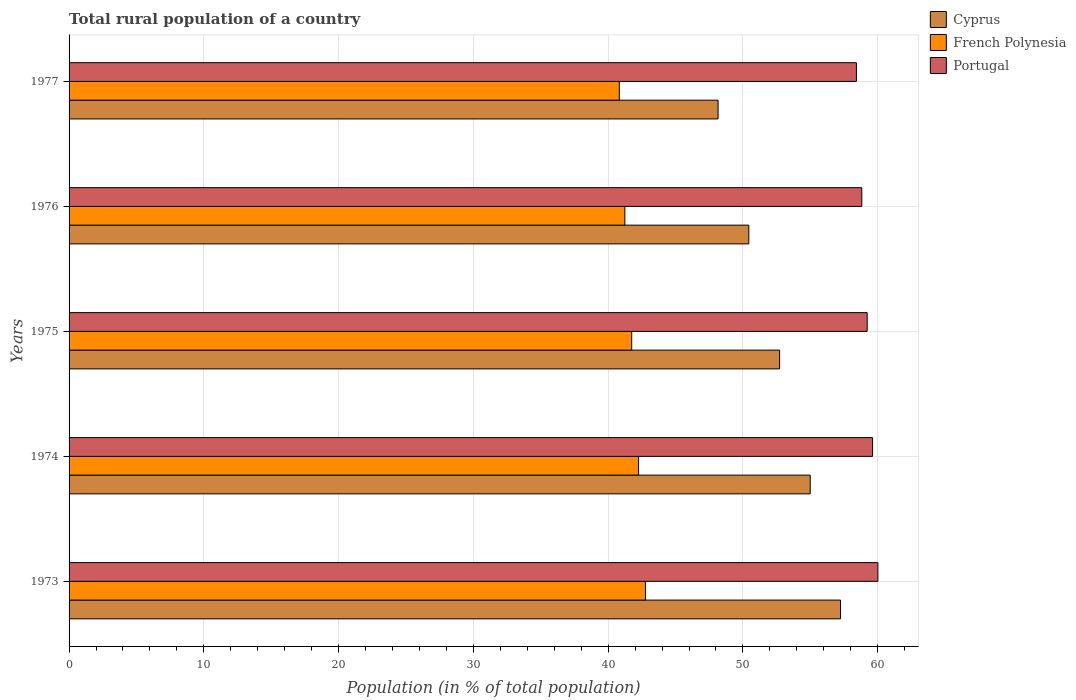How many different coloured bars are there?
Your answer should be compact. 3. Are the number of bars per tick equal to the number of legend labels?
Keep it short and to the point. Yes. Are the number of bars on each tick of the Y-axis equal?
Make the answer very short. Yes. How many bars are there on the 3rd tick from the top?
Provide a succinct answer. 3. How many bars are there on the 1st tick from the bottom?
Ensure brevity in your answer.  3. What is the label of the 3rd group of bars from the top?
Provide a succinct answer. 1975. In how many cases, is the number of bars for a given year not equal to the number of legend labels?
Your answer should be compact. 0. What is the rural population in French Polynesia in 1976?
Your answer should be very brief. 41.24. Across all years, what is the maximum rural population in Cyprus?
Your answer should be very brief. 57.24. Across all years, what is the minimum rural population in Portugal?
Provide a short and direct response. 58.42. What is the total rural population in Portugal in the graph?
Your answer should be compact. 296.1. What is the difference between the rural population in Portugal in 1974 and that in 1976?
Your answer should be compact. 0.8. What is the difference between the rural population in Cyprus in 1973 and the rural population in Portugal in 1976?
Make the answer very short. -1.58. What is the average rural population in French Polynesia per year?
Provide a succinct answer. 41.77. In the year 1977, what is the difference between the rural population in French Polynesia and rural population in Portugal?
Ensure brevity in your answer.  -17.59. What is the ratio of the rural population in Portugal in 1973 to that in 1975?
Give a very brief answer. 1.01. Is the rural population in Portugal in 1973 less than that in 1977?
Provide a short and direct response. No. Is the difference between the rural population in French Polynesia in 1976 and 1977 greater than the difference between the rural population in Portugal in 1976 and 1977?
Your response must be concise. Yes. What is the difference between the highest and the second highest rural population in Cyprus?
Offer a very short reply. 2.25. What is the difference between the highest and the lowest rural population in French Polynesia?
Your answer should be very brief. 1.94. Is the sum of the rural population in French Polynesia in 1973 and 1975 greater than the maximum rural population in Portugal across all years?
Ensure brevity in your answer.  Yes. What does the 3rd bar from the top in 1977 represents?
Keep it short and to the point. Cyprus. What does the 3rd bar from the bottom in 1975 represents?
Your answer should be compact. Portugal. Is it the case that in every year, the sum of the rural population in Cyprus and rural population in Portugal is greater than the rural population in French Polynesia?
Provide a short and direct response. Yes. Are all the bars in the graph horizontal?
Give a very brief answer. Yes. What is the difference between two consecutive major ticks on the X-axis?
Offer a very short reply. 10. Does the graph contain grids?
Your answer should be very brief. Yes. Where does the legend appear in the graph?
Give a very brief answer. Top right. How are the legend labels stacked?
Your answer should be compact. Vertical. What is the title of the graph?
Offer a very short reply. Total rural population of a country. Does "Armenia" appear as one of the legend labels in the graph?
Your response must be concise. No. What is the label or title of the X-axis?
Make the answer very short. Population (in % of total population). What is the Population (in % of total population) of Cyprus in 1973?
Offer a terse response. 57.24. What is the Population (in % of total population) in French Polynesia in 1973?
Offer a very short reply. 42.77. What is the Population (in % of total population) of Portugal in 1973?
Your answer should be compact. 60.02. What is the Population (in % of total population) of Cyprus in 1974?
Offer a very short reply. 54.99. What is the Population (in % of total population) in French Polynesia in 1974?
Ensure brevity in your answer.  42.26. What is the Population (in % of total population) in Portugal in 1974?
Keep it short and to the point. 59.62. What is the Population (in % of total population) of Cyprus in 1975?
Keep it short and to the point. 52.72. What is the Population (in % of total population) in French Polynesia in 1975?
Your answer should be compact. 41.75. What is the Population (in % of total population) of Portugal in 1975?
Your answer should be very brief. 59.22. What is the Population (in % of total population) in Cyprus in 1976?
Make the answer very short. 50.44. What is the Population (in % of total population) of French Polynesia in 1976?
Your response must be concise. 41.24. What is the Population (in % of total population) of Portugal in 1976?
Ensure brevity in your answer.  58.82. What is the Population (in % of total population) in Cyprus in 1977?
Offer a very short reply. 48.16. What is the Population (in % of total population) of French Polynesia in 1977?
Provide a succinct answer. 40.83. What is the Population (in % of total population) of Portugal in 1977?
Your response must be concise. 58.42. Across all years, what is the maximum Population (in % of total population) in Cyprus?
Offer a terse response. 57.24. Across all years, what is the maximum Population (in % of total population) of French Polynesia?
Offer a terse response. 42.77. Across all years, what is the maximum Population (in % of total population) in Portugal?
Your response must be concise. 60.02. Across all years, what is the minimum Population (in % of total population) of Cyprus?
Offer a very short reply. 48.16. Across all years, what is the minimum Population (in % of total population) of French Polynesia?
Offer a terse response. 40.83. Across all years, what is the minimum Population (in % of total population) of Portugal?
Provide a succinct answer. 58.42. What is the total Population (in % of total population) in Cyprus in the graph?
Provide a short and direct response. 263.55. What is the total Population (in % of total population) in French Polynesia in the graph?
Offer a terse response. 208.84. What is the total Population (in % of total population) in Portugal in the graph?
Your answer should be very brief. 296.1. What is the difference between the Population (in % of total population) of Cyprus in 1973 and that in 1974?
Your answer should be compact. 2.25. What is the difference between the Population (in % of total population) in French Polynesia in 1973 and that in 1974?
Offer a very short reply. 0.51. What is the difference between the Population (in % of total population) of Portugal in 1973 and that in 1974?
Offer a very short reply. 0.4. What is the difference between the Population (in % of total population) of Cyprus in 1973 and that in 1975?
Provide a succinct answer. 4.52. What is the difference between the Population (in % of total population) of Portugal in 1973 and that in 1975?
Your answer should be compact. 0.79. What is the difference between the Population (in % of total population) of Cyprus in 1973 and that in 1976?
Ensure brevity in your answer.  6.81. What is the difference between the Population (in % of total population) in French Polynesia in 1973 and that in 1976?
Provide a succinct answer. 1.53. What is the difference between the Population (in % of total population) in Portugal in 1973 and that in 1976?
Ensure brevity in your answer.  1.19. What is the difference between the Population (in % of total population) of Cyprus in 1973 and that in 1977?
Your answer should be very brief. 9.09. What is the difference between the Population (in % of total population) of French Polynesia in 1973 and that in 1977?
Provide a succinct answer. 1.94. What is the difference between the Population (in % of total population) of Portugal in 1973 and that in 1977?
Provide a short and direct response. 1.59. What is the difference between the Population (in % of total population) in Cyprus in 1974 and that in 1975?
Keep it short and to the point. 2.27. What is the difference between the Population (in % of total population) in French Polynesia in 1974 and that in 1975?
Give a very brief answer. 0.51. What is the difference between the Population (in % of total population) in Portugal in 1974 and that in 1975?
Offer a very short reply. 0.4. What is the difference between the Population (in % of total population) in Cyprus in 1974 and that in 1976?
Make the answer very short. 4.56. What is the difference between the Population (in % of total population) of Portugal in 1974 and that in 1976?
Your answer should be compact. 0.8. What is the difference between the Population (in % of total population) in Cyprus in 1974 and that in 1977?
Your answer should be compact. 6.84. What is the difference between the Population (in % of total population) in French Polynesia in 1974 and that in 1977?
Offer a terse response. 1.43. What is the difference between the Population (in % of total population) of Portugal in 1974 and that in 1977?
Offer a terse response. 1.2. What is the difference between the Population (in % of total population) of Cyprus in 1975 and that in 1976?
Your answer should be very brief. 2.29. What is the difference between the Population (in % of total population) in French Polynesia in 1975 and that in 1976?
Offer a very short reply. 0.51. What is the difference between the Population (in % of total population) in Portugal in 1975 and that in 1976?
Your answer should be compact. 0.4. What is the difference between the Population (in % of total population) of Cyprus in 1975 and that in 1977?
Keep it short and to the point. 4.57. What is the difference between the Population (in % of total population) of French Polynesia in 1975 and that in 1977?
Give a very brief answer. 0.92. What is the difference between the Population (in % of total population) in Portugal in 1975 and that in 1977?
Give a very brief answer. 0.8. What is the difference between the Population (in % of total population) of Cyprus in 1976 and that in 1977?
Give a very brief answer. 2.28. What is the difference between the Population (in % of total population) in French Polynesia in 1976 and that in 1977?
Keep it short and to the point. 0.41. What is the difference between the Population (in % of total population) of Portugal in 1976 and that in 1977?
Ensure brevity in your answer.  0.4. What is the difference between the Population (in % of total population) in Cyprus in 1973 and the Population (in % of total population) in French Polynesia in 1974?
Ensure brevity in your answer.  14.98. What is the difference between the Population (in % of total population) in Cyprus in 1973 and the Population (in % of total population) in Portugal in 1974?
Provide a succinct answer. -2.38. What is the difference between the Population (in % of total population) in French Polynesia in 1973 and the Population (in % of total population) in Portugal in 1974?
Your response must be concise. -16.85. What is the difference between the Population (in % of total population) of Cyprus in 1973 and the Population (in % of total population) of French Polynesia in 1975?
Give a very brief answer. 15.49. What is the difference between the Population (in % of total population) of Cyprus in 1973 and the Population (in % of total population) of Portugal in 1975?
Give a very brief answer. -1.98. What is the difference between the Population (in % of total population) in French Polynesia in 1973 and the Population (in % of total population) in Portugal in 1975?
Offer a very short reply. -16.45. What is the difference between the Population (in % of total population) in Cyprus in 1973 and the Population (in % of total population) in French Polynesia in 1976?
Your response must be concise. 16. What is the difference between the Population (in % of total population) of Cyprus in 1973 and the Population (in % of total population) of Portugal in 1976?
Your answer should be compact. -1.58. What is the difference between the Population (in % of total population) of French Polynesia in 1973 and the Population (in % of total population) of Portugal in 1976?
Your response must be concise. -16.05. What is the difference between the Population (in % of total population) of Cyprus in 1973 and the Population (in % of total population) of French Polynesia in 1977?
Your answer should be very brief. 16.41. What is the difference between the Population (in % of total population) in Cyprus in 1973 and the Population (in % of total population) in Portugal in 1977?
Keep it short and to the point. -1.18. What is the difference between the Population (in % of total population) of French Polynesia in 1973 and the Population (in % of total population) of Portugal in 1977?
Your answer should be very brief. -15.65. What is the difference between the Population (in % of total population) in Cyprus in 1974 and the Population (in % of total population) in French Polynesia in 1975?
Your response must be concise. 13.24. What is the difference between the Population (in % of total population) in Cyprus in 1974 and the Population (in % of total population) in Portugal in 1975?
Provide a short and direct response. -4.23. What is the difference between the Population (in % of total population) of French Polynesia in 1974 and the Population (in % of total population) of Portugal in 1975?
Provide a succinct answer. -16.96. What is the difference between the Population (in % of total population) of Cyprus in 1974 and the Population (in % of total population) of French Polynesia in 1976?
Your answer should be compact. 13.75. What is the difference between the Population (in % of total population) of Cyprus in 1974 and the Population (in % of total population) of Portugal in 1976?
Offer a very short reply. -3.83. What is the difference between the Population (in % of total population) in French Polynesia in 1974 and the Population (in % of total population) in Portugal in 1976?
Give a very brief answer. -16.56. What is the difference between the Population (in % of total population) in Cyprus in 1974 and the Population (in % of total population) in French Polynesia in 1977?
Keep it short and to the point. 14.16. What is the difference between the Population (in % of total population) in Cyprus in 1974 and the Population (in % of total population) in Portugal in 1977?
Make the answer very short. -3.43. What is the difference between the Population (in % of total population) in French Polynesia in 1974 and the Population (in % of total population) in Portugal in 1977?
Provide a short and direct response. -16.16. What is the difference between the Population (in % of total population) in Cyprus in 1975 and the Population (in % of total population) in French Polynesia in 1976?
Offer a very short reply. 11.48. What is the difference between the Population (in % of total population) of Cyprus in 1975 and the Population (in % of total population) of Portugal in 1976?
Provide a succinct answer. -6.1. What is the difference between the Population (in % of total population) in French Polynesia in 1975 and the Population (in % of total population) in Portugal in 1976?
Keep it short and to the point. -17.07. What is the difference between the Population (in % of total population) of Cyprus in 1975 and the Population (in % of total population) of French Polynesia in 1977?
Keep it short and to the point. 11.89. What is the difference between the Population (in % of total population) in Cyprus in 1975 and the Population (in % of total population) in Portugal in 1977?
Provide a succinct answer. -5.7. What is the difference between the Population (in % of total population) in French Polynesia in 1975 and the Population (in % of total population) in Portugal in 1977?
Your answer should be compact. -16.67. What is the difference between the Population (in % of total population) in Cyprus in 1976 and the Population (in % of total population) in French Polynesia in 1977?
Make the answer very short. 9.61. What is the difference between the Population (in % of total population) of Cyprus in 1976 and the Population (in % of total population) of Portugal in 1977?
Give a very brief answer. -7.99. What is the difference between the Population (in % of total population) of French Polynesia in 1976 and the Population (in % of total population) of Portugal in 1977?
Offer a terse response. -17.18. What is the average Population (in % of total population) in Cyprus per year?
Give a very brief answer. 52.71. What is the average Population (in % of total population) of French Polynesia per year?
Make the answer very short. 41.77. What is the average Population (in % of total population) in Portugal per year?
Give a very brief answer. 59.22. In the year 1973, what is the difference between the Population (in % of total population) in Cyprus and Population (in % of total population) in French Polynesia?
Your answer should be compact. 14.47. In the year 1973, what is the difference between the Population (in % of total population) in Cyprus and Population (in % of total population) in Portugal?
Provide a succinct answer. -2.77. In the year 1973, what is the difference between the Population (in % of total population) of French Polynesia and Population (in % of total population) of Portugal?
Provide a succinct answer. -17.25. In the year 1974, what is the difference between the Population (in % of total population) in Cyprus and Population (in % of total population) in French Polynesia?
Your answer should be compact. 12.73. In the year 1974, what is the difference between the Population (in % of total population) of Cyprus and Population (in % of total population) of Portugal?
Give a very brief answer. -4.62. In the year 1974, what is the difference between the Population (in % of total population) of French Polynesia and Population (in % of total population) of Portugal?
Your answer should be very brief. -17.36. In the year 1975, what is the difference between the Population (in % of total population) in Cyprus and Population (in % of total population) in French Polynesia?
Offer a very short reply. 10.97. In the year 1975, what is the difference between the Population (in % of total population) in Cyprus and Population (in % of total population) in Portugal?
Provide a succinct answer. -6.5. In the year 1975, what is the difference between the Population (in % of total population) of French Polynesia and Population (in % of total population) of Portugal?
Your answer should be very brief. -17.47. In the year 1976, what is the difference between the Population (in % of total population) of Cyprus and Population (in % of total population) of French Polynesia?
Offer a very short reply. 9.2. In the year 1976, what is the difference between the Population (in % of total population) in Cyprus and Population (in % of total population) in Portugal?
Offer a very short reply. -8.38. In the year 1976, what is the difference between the Population (in % of total population) in French Polynesia and Population (in % of total population) in Portugal?
Keep it short and to the point. -17.58. In the year 1977, what is the difference between the Population (in % of total population) of Cyprus and Population (in % of total population) of French Polynesia?
Provide a succinct answer. 7.33. In the year 1977, what is the difference between the Population (in % of total population) of Cyprus and Population (in % of total population) of Portugal?
Keep it short and to the point. -10.27. In the year 1977, what is the difference between the Population (in % of total population) in French Polynesia and Population (in % of total population) in Portugal?
Your answer should be compact. -17.59. What is the ratio of the Population (in % of total population) of Cyprus in 1973 to that in 1974?
Offer a terse response. 1.04. What is the ratio of the Population (in % of total population) of French Polynesia in 1973 to that in 1974?
Make the answer very short. 1.01. What is the ratio of the Population (in % of total population) of Portugal in 1973 to that in 1974?
Give a very brief answer. 1.01. What is the ratio of the Population (in % of total population) in Cyprus in 1973 to that in 1975?
Provide a succinct answer. 1.09. What is the ratio of the Population (in % of total population) in French Polynesia in 1973 to that in 1975?
Offer a very short reply. 1.02. What is the ratio of the Population (in % of total population) in Portugal in 1973 to that in 1975?
Ensure brevity in your answer.  1.01. What is the ratio of the Population (in % of total population) in Cyprus in 1973 to that in 1976?
Give a very brief answer. 1.13. What is the ratio of the Population (in % of total population) in French Polynesia in 1973 to that in 1976?
Make the answer very short. 1.04. What is the ratio of the Population (in % of total population) of Portugal in 1973 to that in 1976?
Provide a succinct answer. 1.02. What is the ratio of the Population (in % of total population) of Cyprus in 1973 to that in 1977?
Keep it short and to the point. 1.19. What is the ratio of the Population (in % of total population) in French Polynesia in 1973 to that in 1977?
Make the answer very short. 1.05. What is the ratio of the Population (in % of total population) in Portugal in 1973 to that in 1977?
Provide a succinct answer. 1.03. What is the ratio of the Population (in % of total population) of Cyprus in 1974 to that in 1975?
Make the answer very short. 1.04. What is the ratio of the Population (in % of total population) in French Polynesia in 1974 to that in 1975?
Ensure brevity in your answer.  1.01. What is the ratio of the Population (in % of total population) of Cyprus in 1974 to that in 1976?
Keep it short and to the point. 1.09. What is the ratio of the Population (in % of total population) in French Polynesia in 1974 to that in 1976?
Make the answer very short. 1.02. What is the ratio of the Population (in % of total population) in Portugal in 1974 to that in 1976?
Provide a short and direct response. 1.01. What is the ratio of the Population (in % of total population) in Cyprus in 1974 to that in 1977?
Ensure brevity in your answer.  1.14. What is the ratio of the Population (in % of total population) in French Polynesia in 1974 to that in 1977?
Make the answer very short. 1.03. What is the ratio of the Population (in % of total population) of Portugal in 1974 to that in 1977?
Your answer should be compact. 1.02. What is the ratio of the Population (in % of total population) of Cyprus in 1975 to that in 1976?
Your response must be concise. 1.05. What is the ratio of the Population (in % of total population) of French Polynesia in 1975 to that in 1976?
Provide a succinct answer. 1.01. What is the ratio of the Population (in % of total population) in Portugal in 1975 to that in 1976?
Keep it short and to the point. 1.01. What is the ratio of the Population (in % of total population) in Cyprus in 1975 to that in 1977?
Provide a succinct answer. 1.09. What is the ratio of the Population (in % of total population) in French Polynesia in 1975 to that in 1977?
Make the answer very short. 1.02. What is the ratio of the Population (in % of total population) in Portugal in 1975 to that in 1977?
Provide a short and direct response. 1.01. What is the ratio of the Population (in % of total population) of Cyprus in 1976 to that in 1977?
Make the answer very short. 1.05. What is the ratio of the Population (in % of total population) in French Polynesia in 1976 to that in 1977?
Your response must be concise. 1.01. What is the ratio of the Population (in % of total population) in Portugal in 1976 to that in 1977?
Your answer should be very brief. 1.01. What is the difference between the highest and the second highest Population (in % of total population) of Cyprus?
Ensure brevity in your answer.  2.25. What is the difference between the highest and the second highest Population (in % of total population) in French Polynesia?
Give a very brief answer. 0.51. What is the difference between the highest and the second highest Population (in % of total population) in Portugal?
Give a very brief answer. 0.4. What is the difference between the highest and the lowest Population (in % of total population) in Cyprus?
Give a very brief answer. 9.09. What is the difference between the highest and the lowest Population (in % of total population) in French Polynesia?
Your response must be concise. 1.94. What is the difference between the highest and the lowest Population (in % of total population) in Portugal?
Your response must be concise. 1.59. 